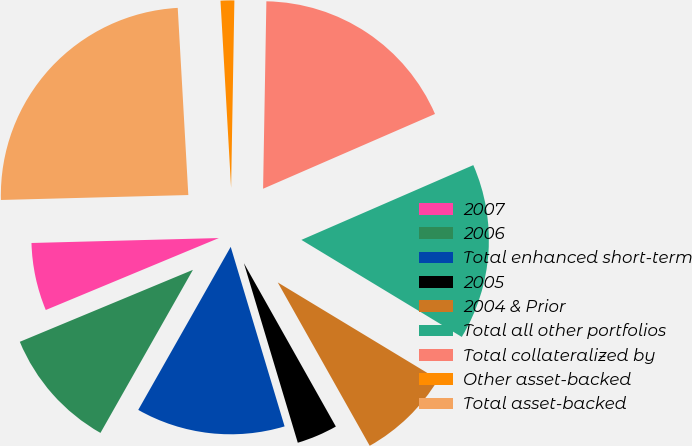Convert chart. <chart><loc_0><loc_0><loc_500><loc_500><pie_chart><fcel>2007<fcel>2006<fcel>Total enhanced short-term<fcel>2005<fcel>2004 & Prior<fcel>Total all other portfolios<fcel>Total collateralized by<fcel>Other asset-backed<fcel>Total asset-backed<nl><fcel>5.85%<fcel>10.52%<fcel>12.85%<fcel>3.52%<fcel>8.18%<fcel>15.19%<fcel>18.19%<fcel>1.18%<fcel>24.52%<nl></chart> 